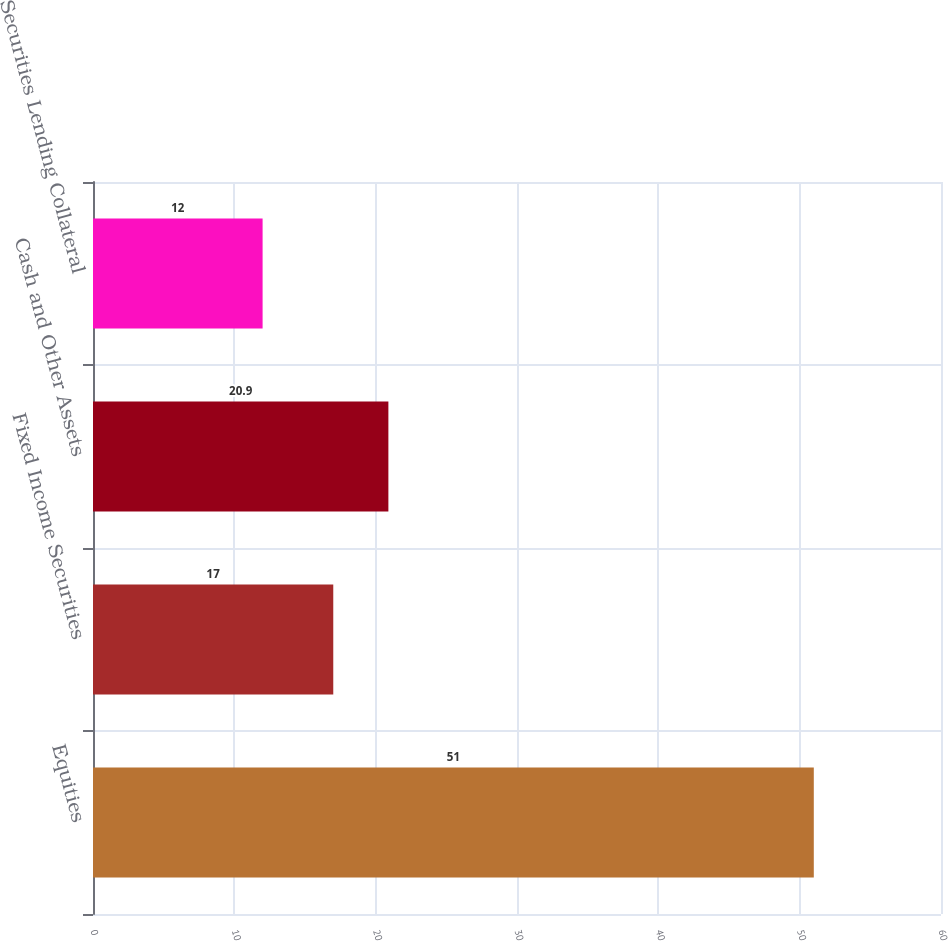Convert chart to OTSL. <chart><loc_0><loc_0><loc_500><loc_500><bar_chart><fcel>Equities<fcel>Fixed Income Securities<fcel>Cash and Other Assets<fcel>Securities Lending Collateral<nl><fcel>51<fcel>17<fcel>20.9<fcel>12<nl></chart> 